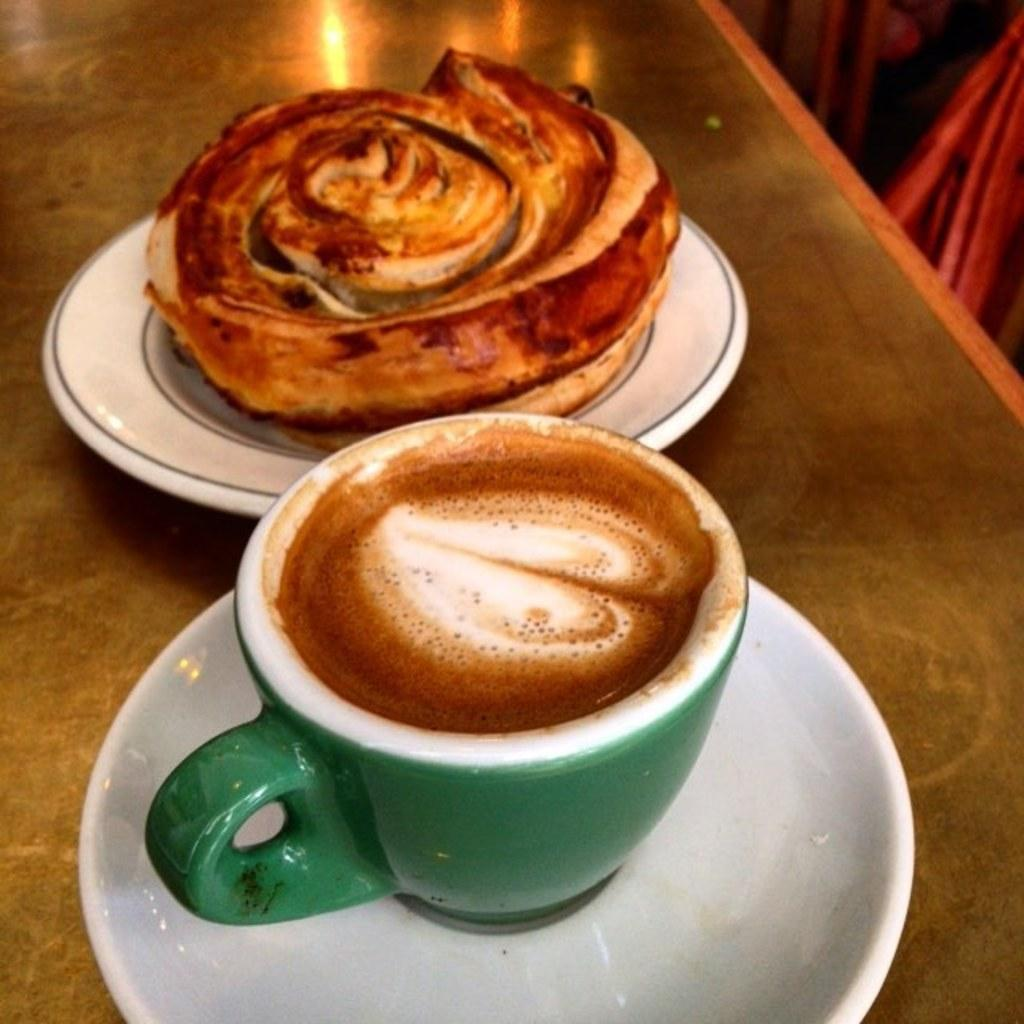What beverage is in the cup that is visible in the image? There is a cup of coffee in the image. What food item is on the plate in the image? The food item on the plate is not specified in the facts provided. Where are the cup of coffee and plate located in the image? The cup of coffee and plate are placed on a table in the image. Can you tell me how many horses are playing the guitar in the image? There are no horses or guitars present in the image. What type of clover can be seen growing on the table in the image? There is no clover visible in the image; the table is occupied by a cup of coffee and a plate with a food item. 